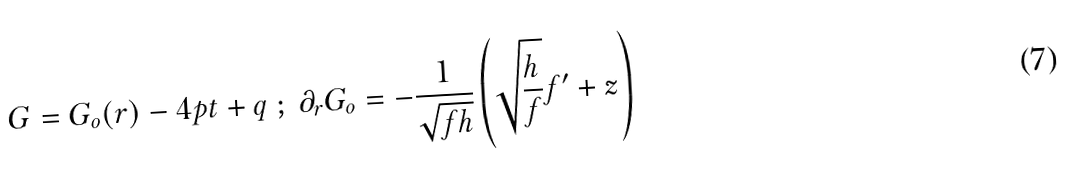<formula> <loc_0><loc_0><loc_500><loc_500>G = G _ { o } ( r ) - 4 p t + q \ ; \ \partial _ { r } G _ { o } = - \frac { 1 } { \sqrt { f h } } \left ( \sqrt { \frac { h } { f } } f ^ { \prime } + z \right )</formula> 